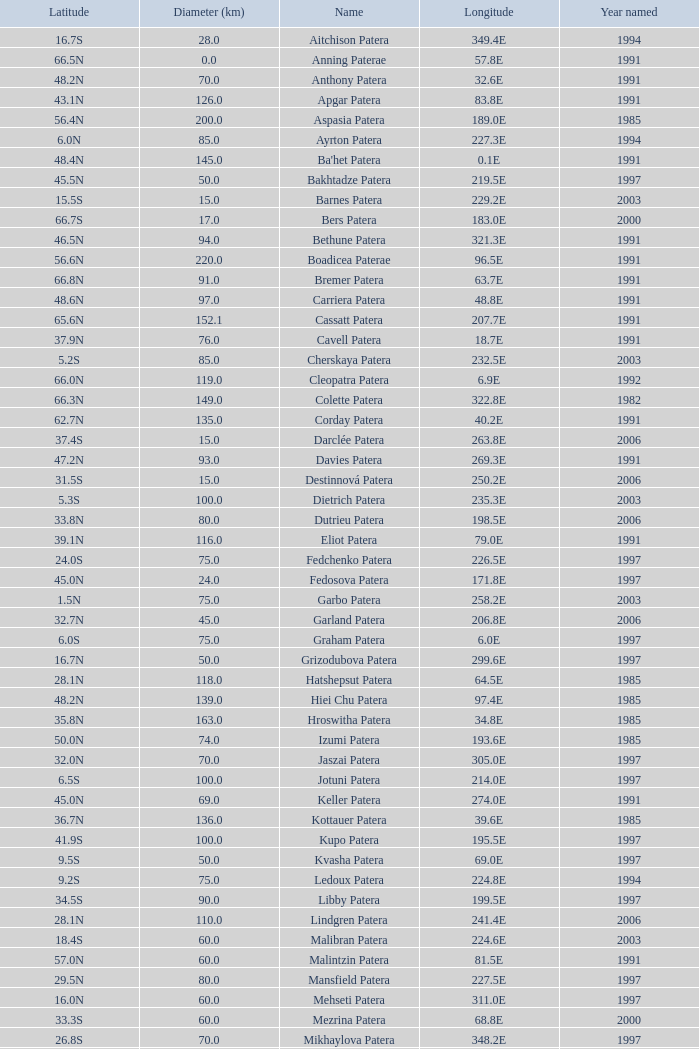What is Year Named, when Longitude is 227.5E? 1997.0. 